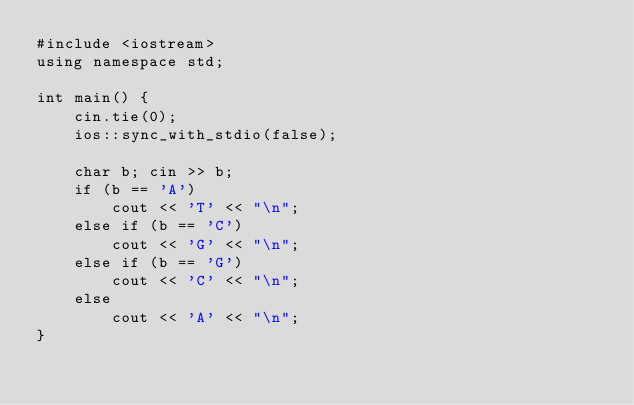<code> <loc_0><loc_0><loc_500><loc_500><_C++_>#include <iostream>
using namespace std;

int main() {
    cin.tie(0);
    ios::sync_with_stdio(false);

    char b; cin >> b;
    if (b == 'A')
        cout << 'T' << "\n";
    else if (b == 'C')
        cout << 'G' << "\n";
    else if (b == 'G')
        cout << 'C' << "\n";
    else
        cout << 'A' << "\n";
}</code> 